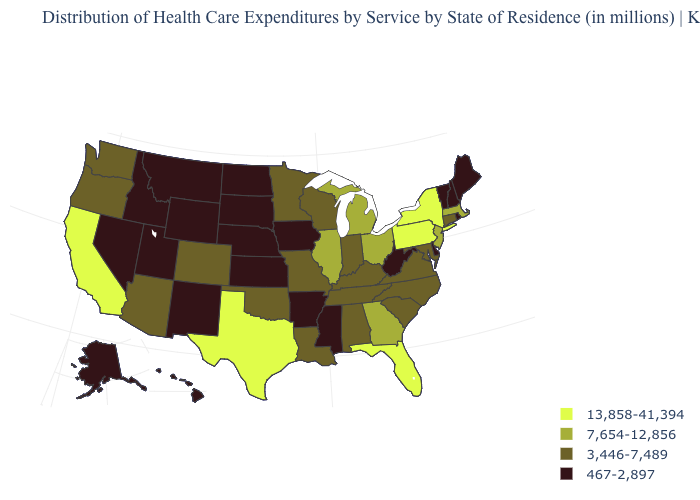What is the value of Virginia?
Short answer required. 3,446-7,489. What is the value of Nevada?
Be succinct. 467-2,897. Name the states that have a value in the range 3,446-7,489?
Write a very short answer. Alabama, Arizona, Colorado, Connecticut, Indiana, Kentucky, Louisiana, Maryland, Minnesota, Missouri, North Carolina, Oklahoma, Oregon, South Carolina, Tennessee, Virginia, Washington, Wisconsin. Does Connecticut have a lower value than North Carolina?
Concise answer only. No. Does the first symbol in the legend represent the smallest category?
Give a very brief answer. No. What is the lowest value in the USA?
Give a very brief answer. 467-2,897. Which states have the lowest value in the South?
Quick response, please. Arkansas, Delaware, Mississippi, West Virginia. Does Pennsylvania have the lowest value in the USA?
Short answer required. No. Name the states that have a value in the range 467-2,897?
Concise answer only. Alaska, Arkansas, Delaware, Hawaii, Idaho, Iowa, Kansas, Maine, Mississippi, Montana, Nebraska, Nevada, New Hampshire, New Mexico, North Dakota, Rhode Island, South Dakota, Utah, Vermont, West Virginia, Wyoming. What is the value of Virginia?
Quick response, please. 3,446-7,489. What is the value of South Dakota?
Keep it brief. 467-2,897. Name the states that have a value in the range 3,446-7,489?
Give a very brief answer. Alabama, Arizona, Colorado, Connecticut, Indiana, Kentucky, Louisiana, Maryland, Minnesota, Missouri, North Carolina, Oklahoma, Oregon, South Carolina, Tennessee, Virginia, Washington, Wisconsin. Among the states that border Kentucky , which have the lowest value?
Short answer required. West Virginia. Name the states that have a value in the range 13,858-41,394?
Concise answer only. California, Florida, New York, Pennsylvania, Texas. What is the highest value in the West ?
Keep it brief. 13,858-41,394. 